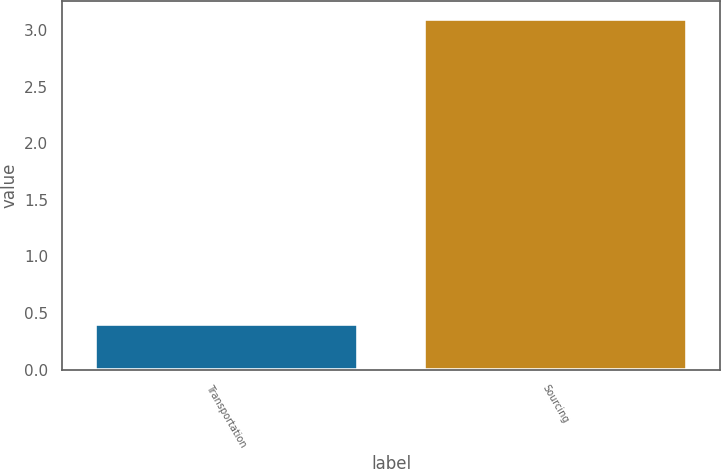Convert chart to OTSL. <chart><loc_0><loc_0><loc_500><loc_500><bar_chart><fcel>Transportation<fcel>Sourcing<nl><fcel>0.4<fcel>3.1<nl></chart> 